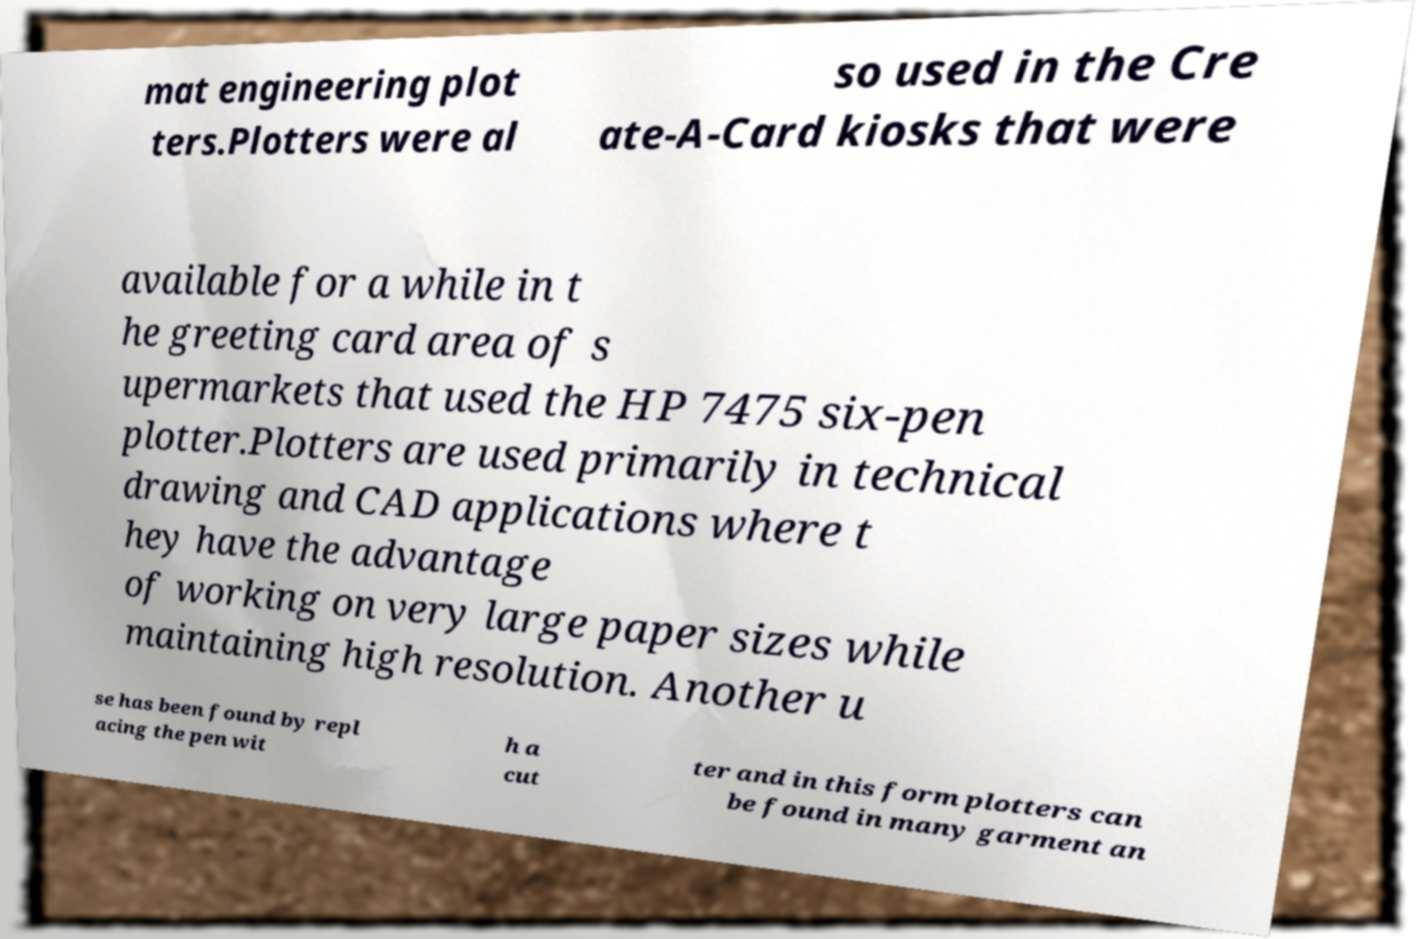Please read and relay the text visible in this image. What does it say? mat engineering plot ters.Plotters were al so used in the Cre ate-A-Card kiosks that were available for a while in t he greeting card area of s upermarkets that used the HP 7475 six-pen plotter.Plotters are used primarily in technical drawing and CAD applications where t hey have the advantage of working on very large paper sizes while maintaining high resolution. Another u se has been found by repl acing the pen wit h a cut ter and in this form plotters can be found in many garment an 